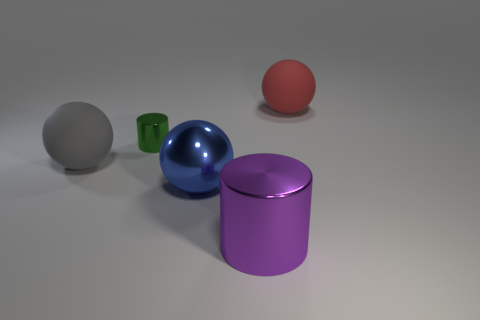Subtract all gray balls. How many balls are left? 2 Add 1 big shiny spheres. How many objects exist? 6 Subtract all cylinders. How many objects are left? 3 Subtract all yellow balls. Subtract all brown cubes. How many balls are left? 3 Add 5 blue metallic balls. How many blue metallic balls exist? 6 Subtract 1 purple cylinders. How many objects are left? 4 Subtract all big matte things. Subtract all blue matte cylinders. How many objects are left? 3 Add 3 red matte things. How many red matte things are left? 4 